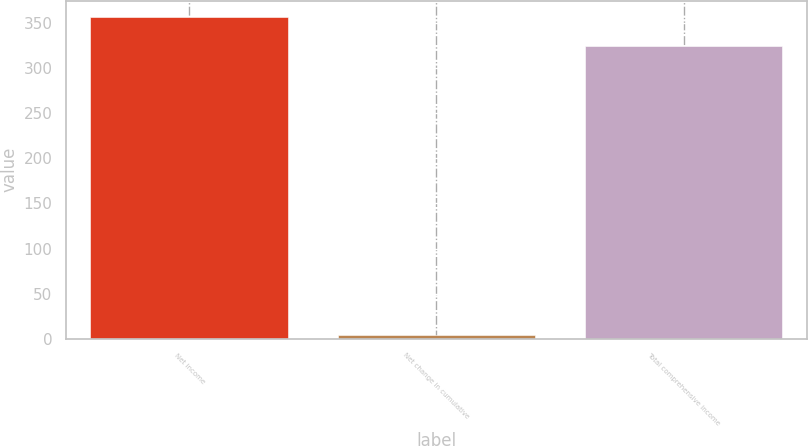Convert chart to OTSL. <chart><loc_0><loc_0><loc_500><loc_500><bar_chart><fcel>Net income<fcel>Net change in cumulative<fcel>Total comprehensive income<nl><fcel>356.73<fcel>4.6<fcel>324.3<nl></chart> 